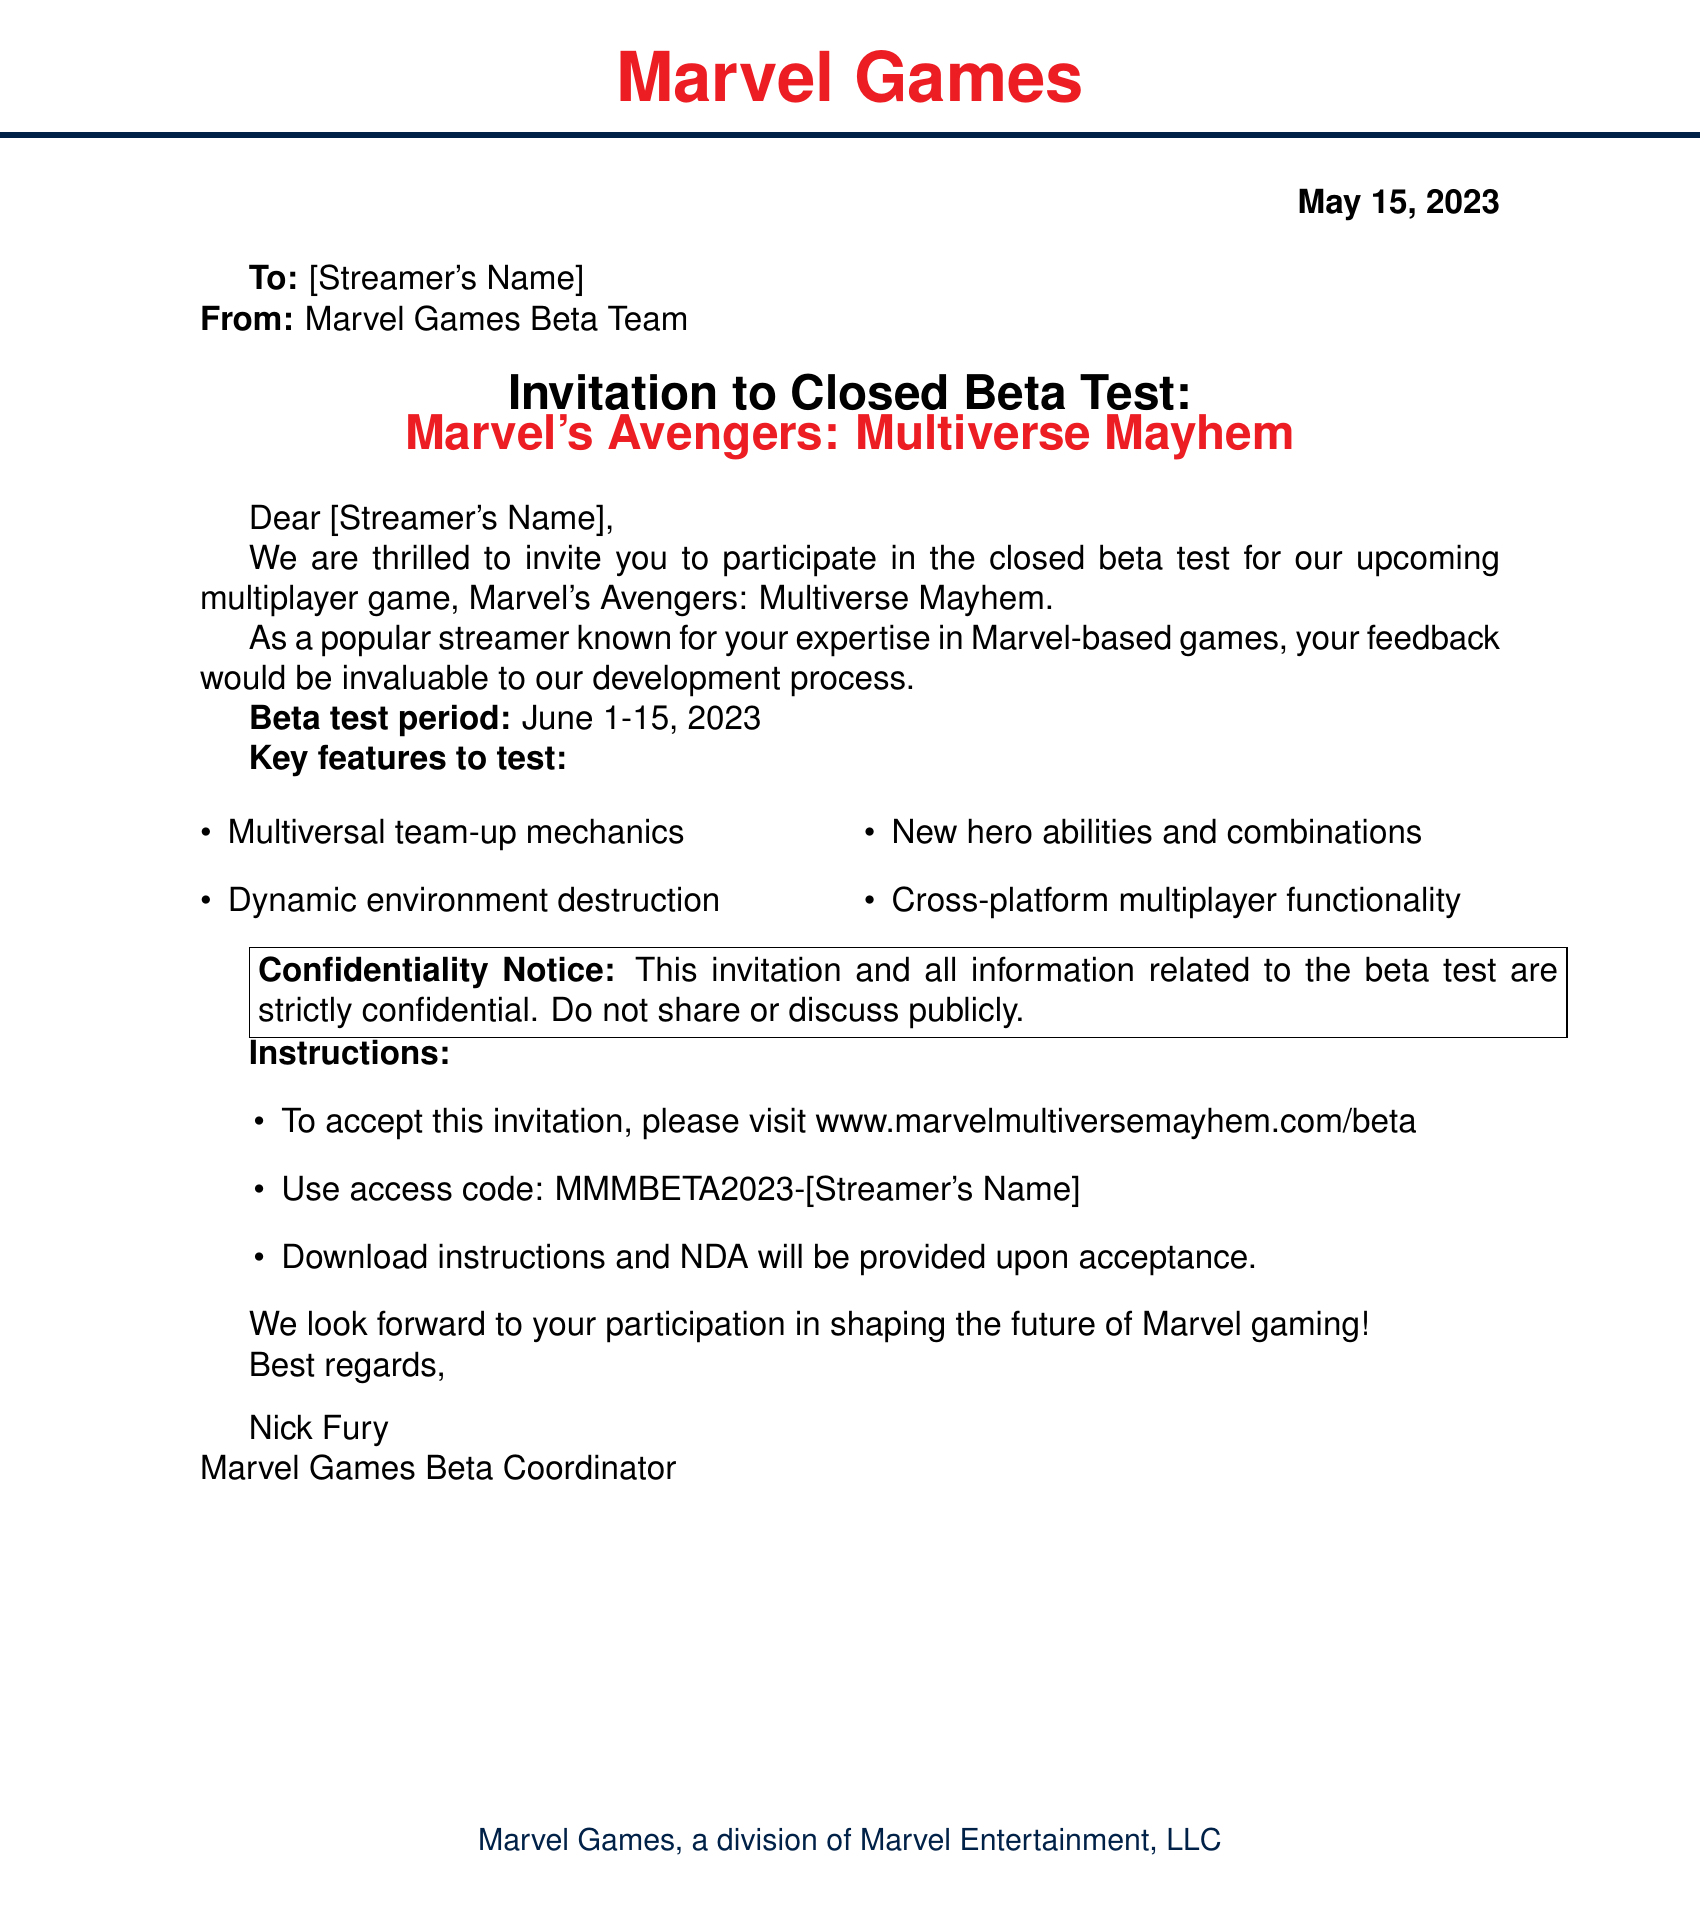What is the name of the game being tested? The game being tested is mentioned in the title of the invitation.
Answer: Marvel's Avengers: Multiverse Mayhem Who is the invitation addressed to? The invitation is directed to a specific person, identified as [Streamer's Name].
Answer: [Streamer's Name] What are the dates of the beta test period? The beta test period is clearly stated in the document.
Answer: June 1-15, 2023 Who is the sender of this invitation? The sender's name is provided in the closing of the invitation.
Answer: Nick Fury What is the access code for the beta test? The document specifies the access code needed to accept the invitation.
Answer: MMMBETA2023-[Streamer's Name] What are the first two key features to test? The document includes a list of key features, the first two of which are relevant to this question.
Answer: Multiversal team-up mechanics, Dynamic environment destruction What must the recipient do to accept the invitation? The instructions provide a clear action required for acceptance of the invitation.
Answer: Visit www.marvelmultiversemayhem.com/beta What is the confidentiality notice about? The confidentiality notice outlines the restrictions regarding information sharing in the invitation.
Answer: Strictly confidential What type of document is this invitation? The format and content indicate the purpose and nature of the document being sent.
Answer: Faxed invitation 